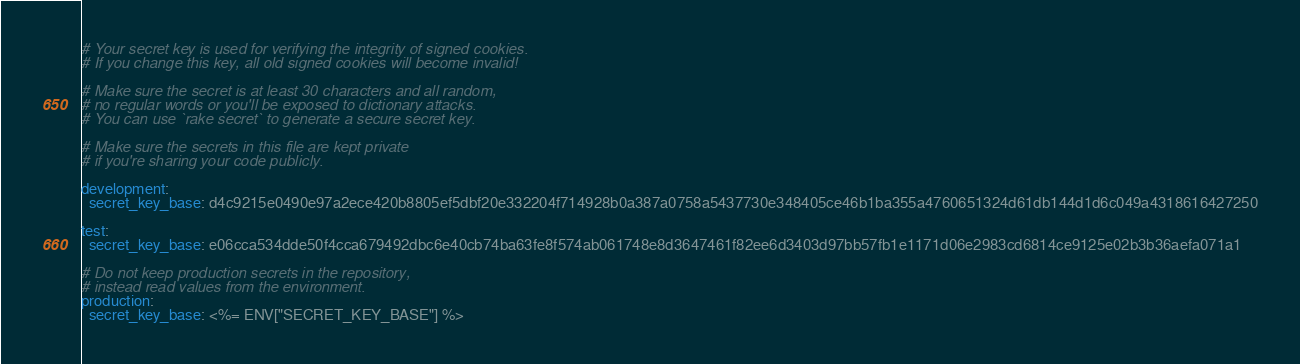Convert code to text. <code><loc_0><loc_0><loc_500><loc_500><_YAML_># Your secret key is used for verifying the integrity of signed cookies.
# If you change this key, all old signed cookies will become invalid!

# Make sure the secret is at least 30 characters and all random,
# no regular words or you'll be exposed to dictionary attacks.
# You can use `rake secret` to generate a secure secret key.

# Make sure the secrets in this file are kept private
# if you're sharing your code publicly.

development:
  secret_key_base: d4c9215e0490e97a2ece420b8805ef5dbf20e332204f714928b0a387a0758a5437730e348405ce46b1ba355a4760651324d61db144d1d6c049a4318616427250

test:
  secret_key_base: e06cca534dde50f4cca679492dbc6e40cb74ba63fe8f574ab061748e8d3647461f82ee6d3403d97bb57fb1e1171d06e2983cd6814ce9125e02b3b36aefa071a1

# Do not keep production secrets in the repository,
# instead read values from the environment.
production:
  secret_key_base: <%= ENV["SECRET_KEY_BASE"] %>
</code> 